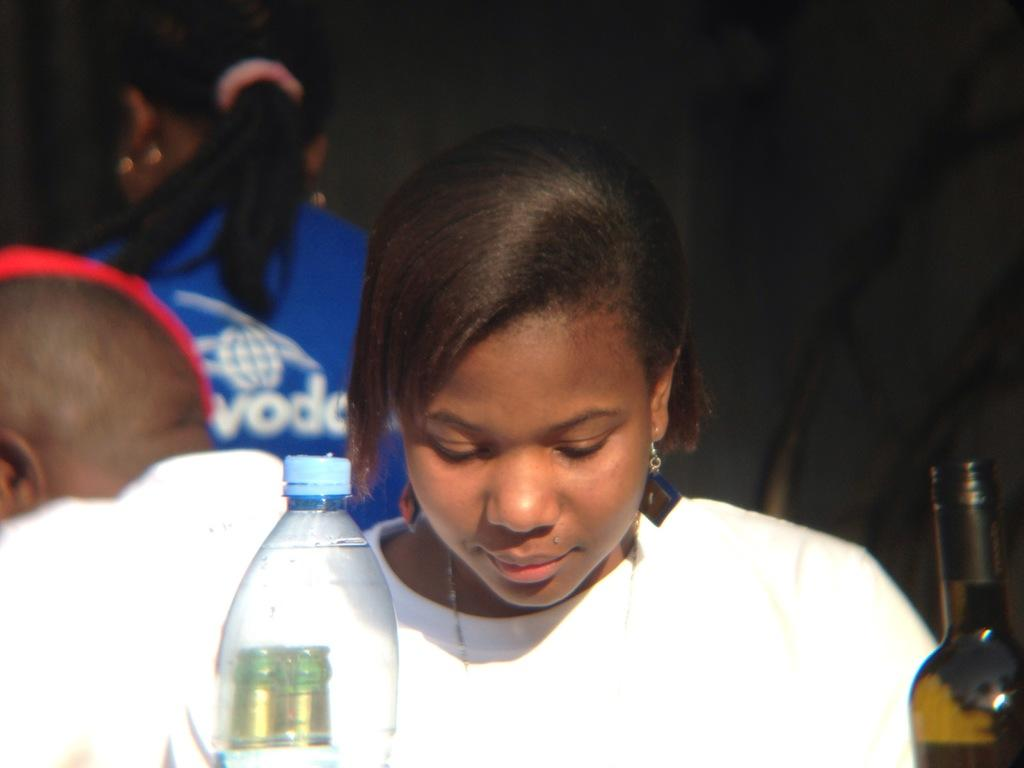Who is present in the image? There is a woman in the image. What is the woman doing in the image? The woman is sitting at a table. What objects can be seen on the table? There are bottles on the table. What type of polish is the woman applying to her nails in the image? There is no indication in the image that the woman is applying any polish to her nails. 